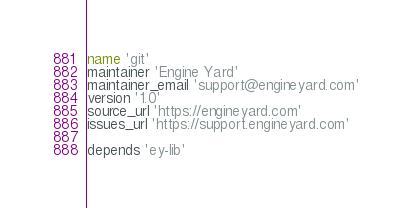Convert code to text. <code><loc_0><loc_0><loc_500><loc_500><_Ruby_>name 'git'
maintainer 'Engine Yard'
maintainer_email 'support@engineyard.com'
version '1.0'
source_url 'https://engineyard.com'
issues_url 'https://support.engineyard.com'

depends 'ey-lib'
</code> 